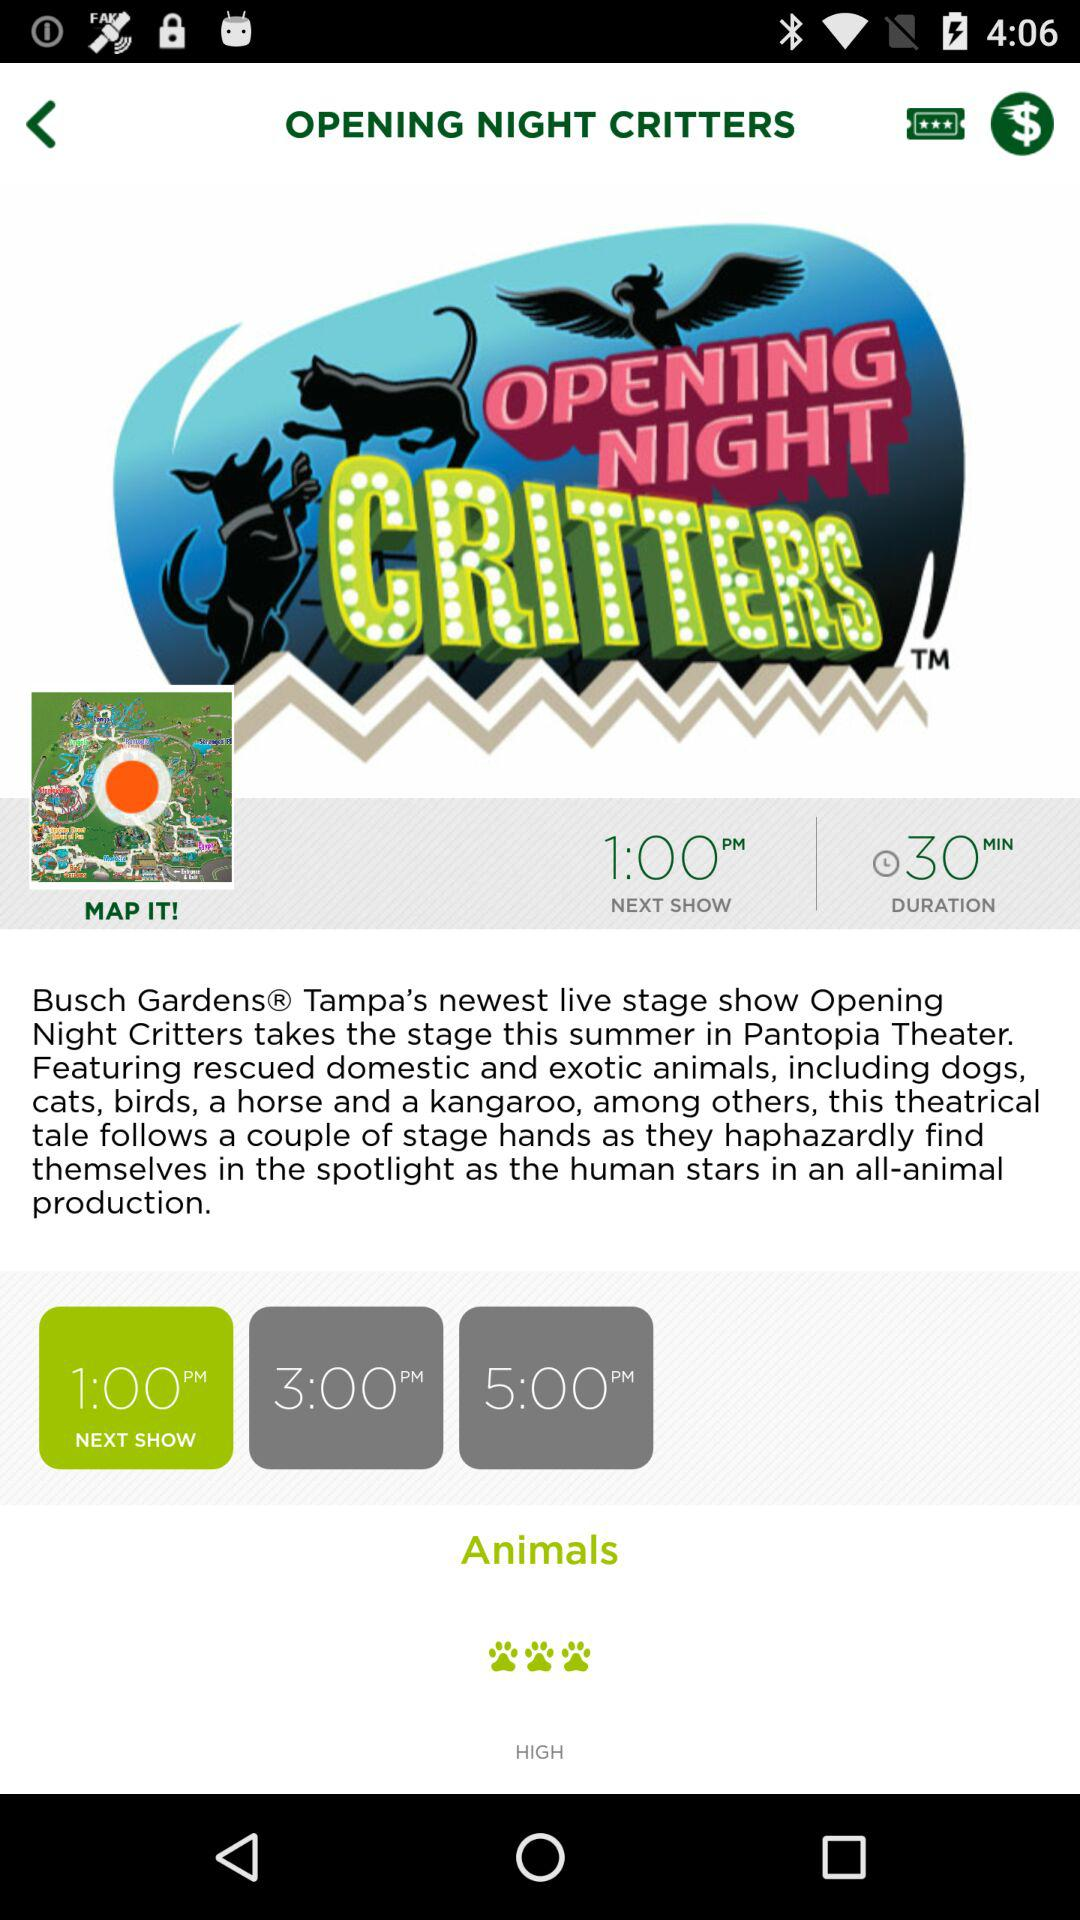What is the name of the application?
When the provided information is insufficient, respond with <no answer>. <no answer> 